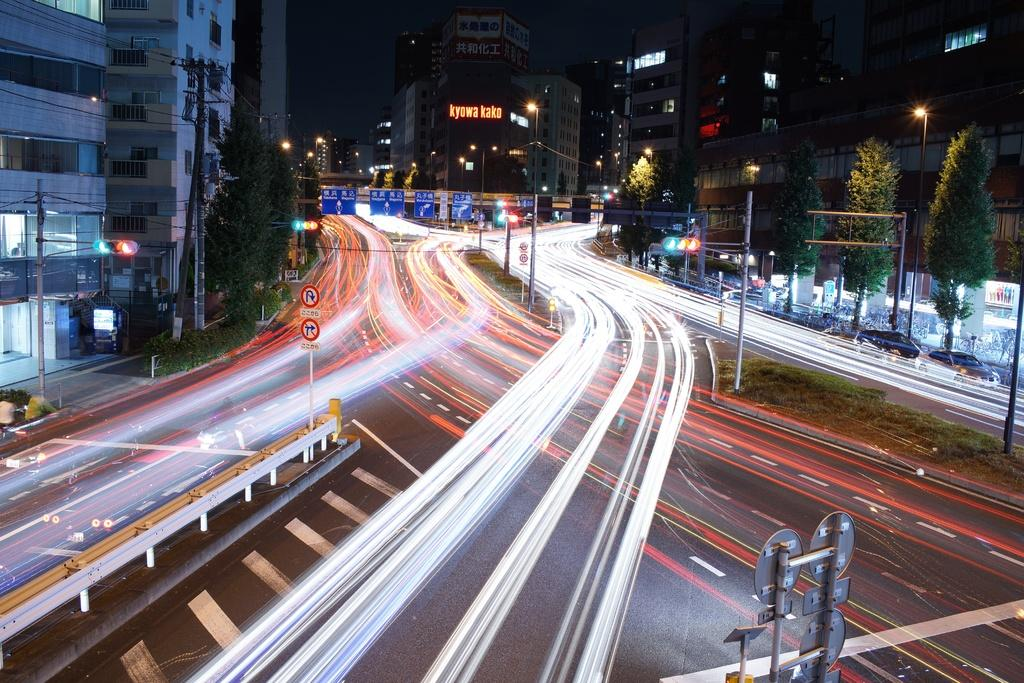What is attached to the pole in the image? There is a board attached to a pole in the image. What type of infrastructure can be seen in the image? Roads, light poles, current poles, and buildings are visible in the image. What type of vegetation is present in the image? Trees are visible in the image. What type of vehicles are parked in the image? Cars are parked in the image. What is the color of the sky in the background of the image? The sky in the background of the image is dark. How many pizzas are being delivered in the image? There are no pizzas or delivery in the image. What year is depicted in the image? The image does not depict a specific year; it is a snapshot of a scene. 